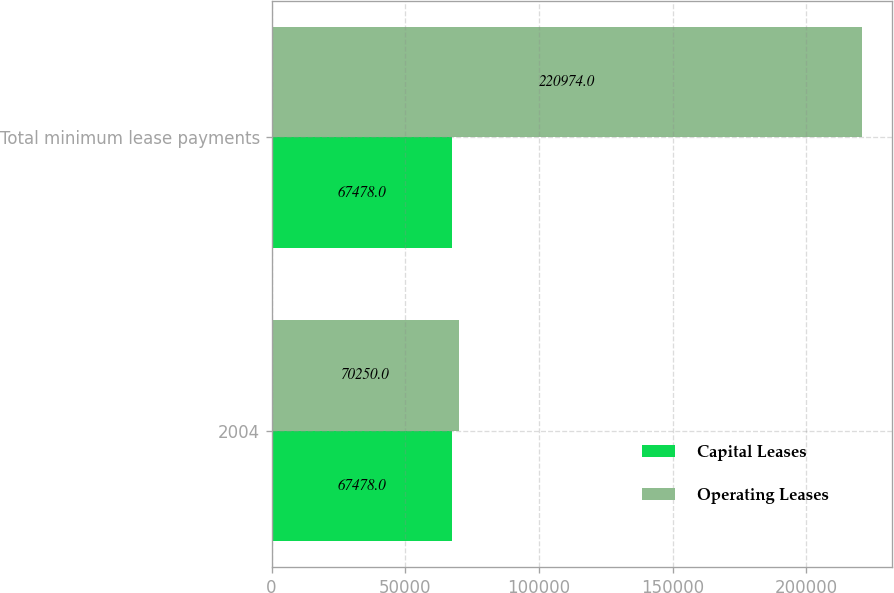<chart> <loc_0><loc_0><loc_500><loc_500><stacked_bar_chart><ecel><fcel>2004<fcel>Total minimum lease payments<nl><fcel>Capital Leases<fcel>67478<fcel>67478<nl><fcel>Operating Leases<fcel>70250<fcel>220974<nl></chart> 